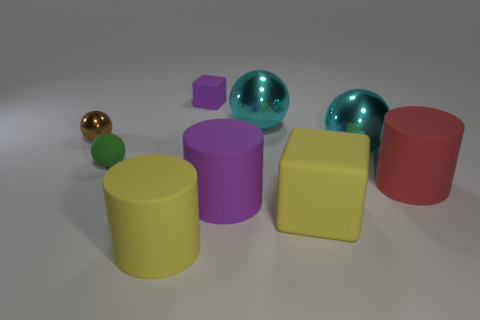Is there a big rubber thing of the same color as the tiny rubber block?
Make the answer very short. Yes. How many other things are the same size as the rubber ball?
Keep it short and to the point. 2. Is the small matte cube the same color as the tiny metallic thing?
Provide a succinct answer. No. What color is the big metal sphere that is on the right side of the big cyan metal object that is on the left side of the large cyan metal object in front of the tiny shiny object?
Your answer should be compact. Cyan. What number of small matte spheres are behind the large cyan metallic ball behind the cyan metallic thing that is in front of the brown object?
Your answer should be very brief. 0. Is there any other thing that is the same color as the small cube?
Offer a terse response. Yes. Is the size of the yellow rubber object behind the yellow cylinder the same as the purple rubber cylinder?
Provide a short and direct response. Yes. How many yellow matte cubes are right of the purple object that is to the right of the small purple thing?
Offer a terse response. 1. There is a large cyan object that is to the left of the big metallic object that is in front of the brown object; is there a big yellow rubber cylinder on the left side of it?
Give a very brief answer. Yes. What material is the small brown object that is the same shape as the small green matte thing?
Your answer should be very brief. Metal. 